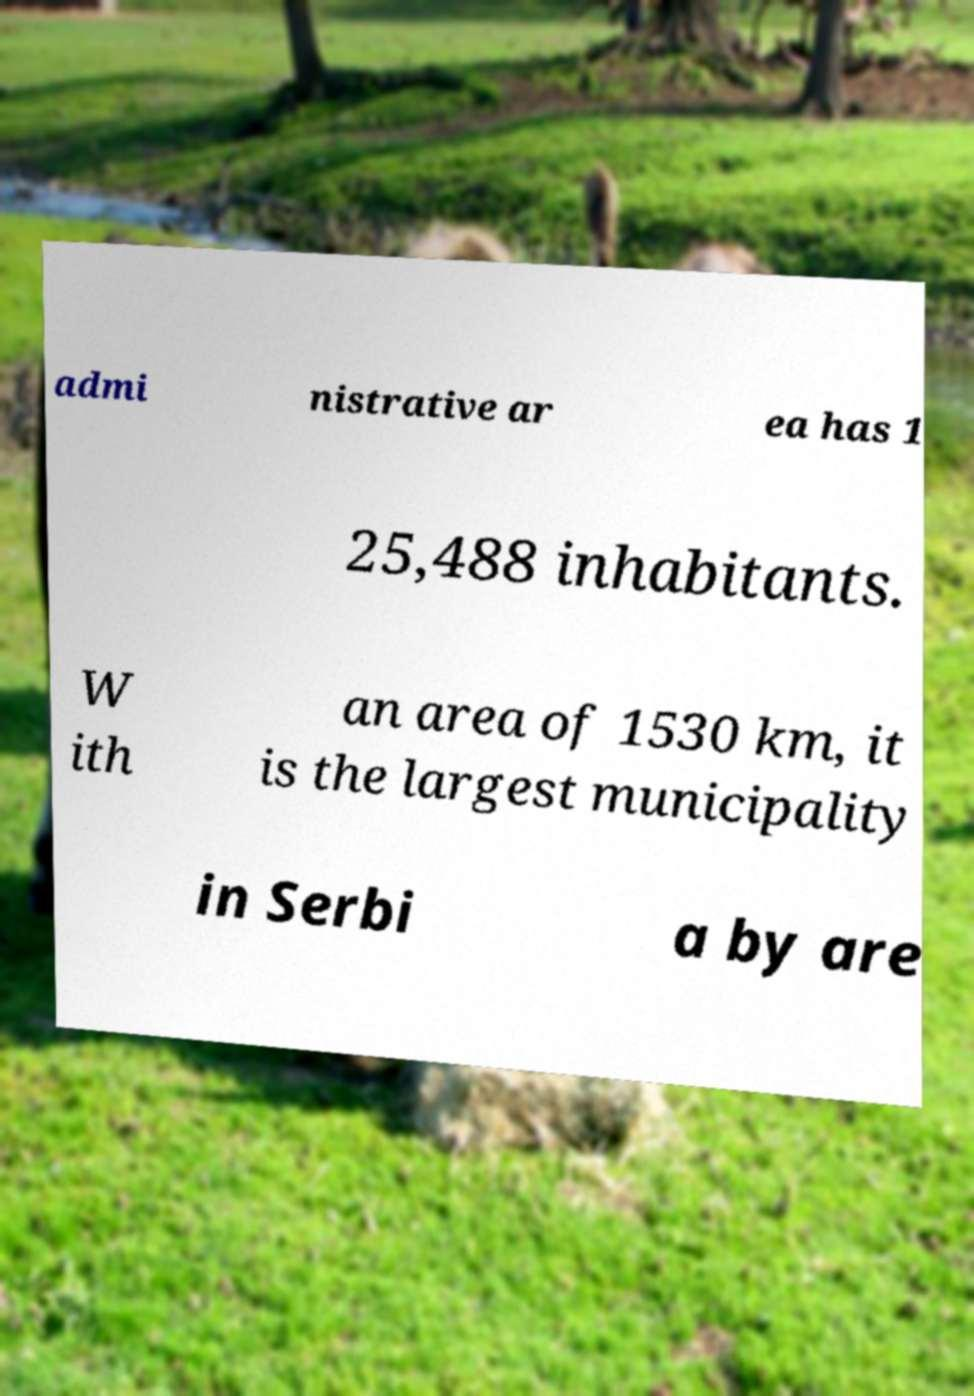Please read and relay the text visible in this image. What does it say? admi nistrative ar ea has 1 25,488 inhabitants. W ith an area of 1530 km, it is the largest municipality in Serbi a by are 